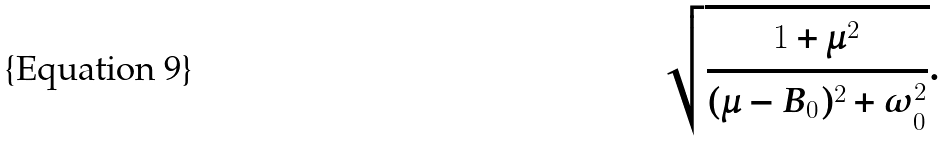<formula> <loc_0><loc_0><loc_500><loc_500>\sqrt { \frac { 1 + \mu ^ { 2 } } { ( \mu - B _ { 0 } ) ^ { 2 } + \omega _ { 0 } ^ { 2 } } } .</formula> 